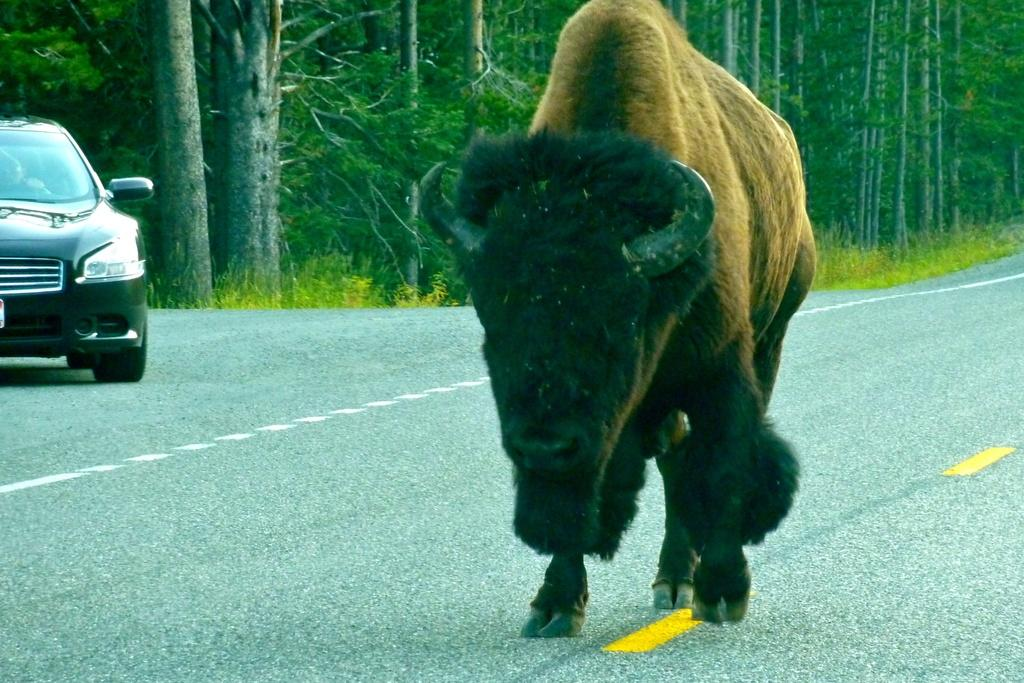What type of animal can be seen in the image? There is an animal, possibly a bull, in the image. Where is the animal located? The animal is on the road. What else can be seen on the road in the image? There is a car on the left side of the image. What type of vegetation is visible in the background of the image? There is grass and trees visible in the background of the image. Can you describe the trees in the background? Tree trunks are present in the background of the image. What decision does the bean make in the image? There is no bean present in the image, and therefore no decision can be made by a bean. 